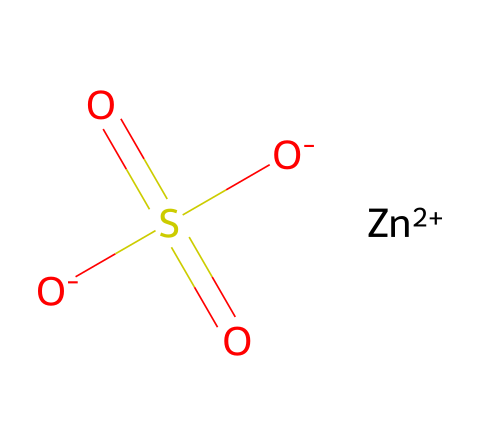what is the central metal in this compound? The structure includes the ion Zn+2, which indicates that zinc is the central metal in this chemical composition.
Answer: zinc how many oxygen atoms are present in the structure? By analyzing the SMILES, it shows two O atoms connected to the sulfur and another O atom in the sulfate group, resulting in three oxygen atoms.
Answer: three what type of bonding is present between zinc and the sulfate anion? Zinc forms ionic bonds with the sulfate ion because it has a +2 charge, while the sulfate has a net -2 charge, leading to electrostatic attraction.
Answer: ionic what does the presence of sulfur in the compound indicate about its type? The presence of the sulfur atom shows that this compound includes a sulfate group, which is characteristic of inorganic salts.
Answer: inorganic salt how does weathering affect the zinc in roofing materials? Weathering causes zinc to oxidize, leading to corrosion of roofing materials that can release zinc ions into the environment.
Answer: oxidation what can be inferred about the stability of the compound with the +2 oxidation state of zinc? The +2 oxidation state of zinc suggests that it is stable in many environments, especially when considering its role in preventing corrosion in roofing materials.
Answer: stable 